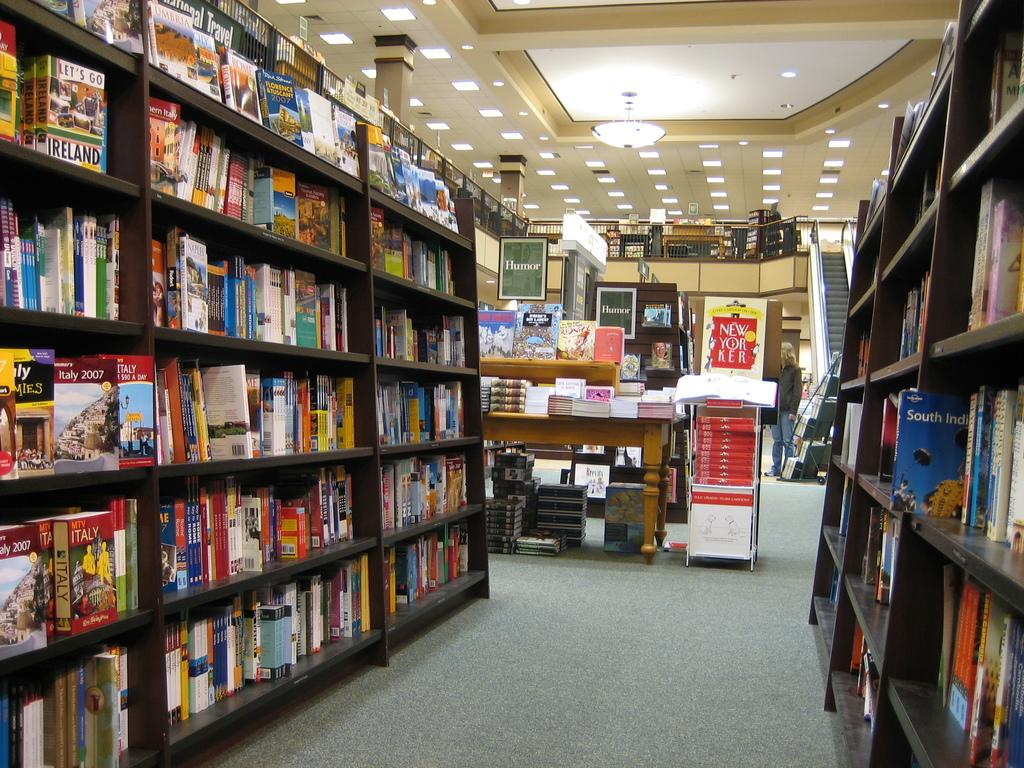<image>
Share a concise interpretation of the image provided. A rack advertising the New Yorker has a stack of issues and stands next to a shelf full of books. 